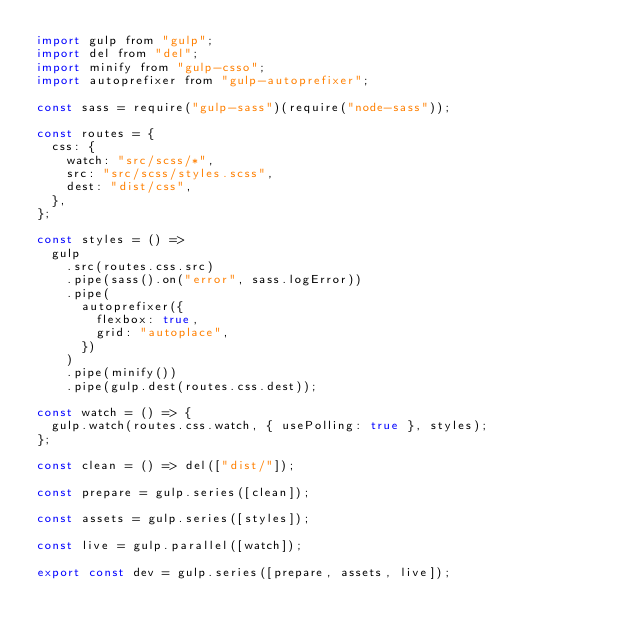<code> <loc_0><loc_0><loc_500><loc_500><_JavaScript_>import gulp from "gulp";
import del from "del";
import minify from "gulp-csso";
import autoprefixer from "gulp-autoprefixer";

const sass = require("gulp-sass")(require("node-sass"));

const routes = {
  css: {
    watch: "src/scss/*",
    src: "src/scss/styles.scss",
    dest: "dist/css",
  },
};

const styles = () =>
  gulp
    .src(routes.css.src)
    .pipe(sass().on("error", sass.logError))
    .pipe(
      autoprefixer({
        flexbox: true,
        grid: "autoplace",
      })
    )
    .pipe(minify())
    .pipe(gulp.dest(routes.css.dest));

const watch = () => {
  gulp.watch(routes.css.watch, { usePolling: true }, styles);
};

const clean = () => del(["dist/"]);

const prepare = gulp.series([clean]);

const assets = gulp.series([styles]);

const live = gulp.parallel([watch]);

export const dev = gulp.series([prepare, assets, live]);
</code> 